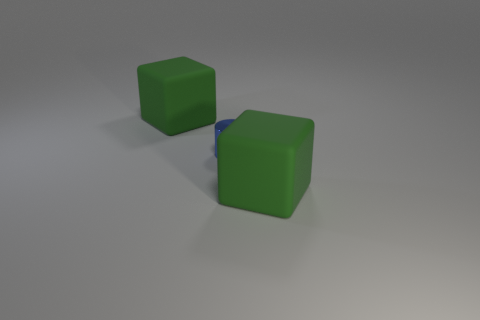There is a matte block that is to the left of the metal thing that is on the right side of the big thing that is behind the shiny object; what size is it?
Make the answer very short. Large. Are there any blue metal cylinders to the left of the green rubber thing to the right of the green block that is behind the tiny shiny thing?
Provide a succinct answer. Yes. Is the number of shiny objects greater than the number of blocks?
Give a very brief answer. No. What color is the cube that is in front of the tiny metallic object?
Make the answer very short. Green. Are there more rubber things that are right of the tiny blue cylinder than small gray matte cylinders?
Keep it short and to the point. Yes. How many other objects are the same shape as the small thing?
Offer a very short reply. 0. Is there anything else that has the same material as the small blue cylinder?
Make the answer very short. No. There is a matte thing that is in front of the large matte thing that is to the left of the object that is to the right of the small cylinder; what is its color?
Your answer should be very brief. Green. Do the big green object that is in front of the tiny blue metallic cylinder and the tiny object have the same shape?
Offer a very short reply. No. How many matte things are there?
Your answer should be compact. 2. 